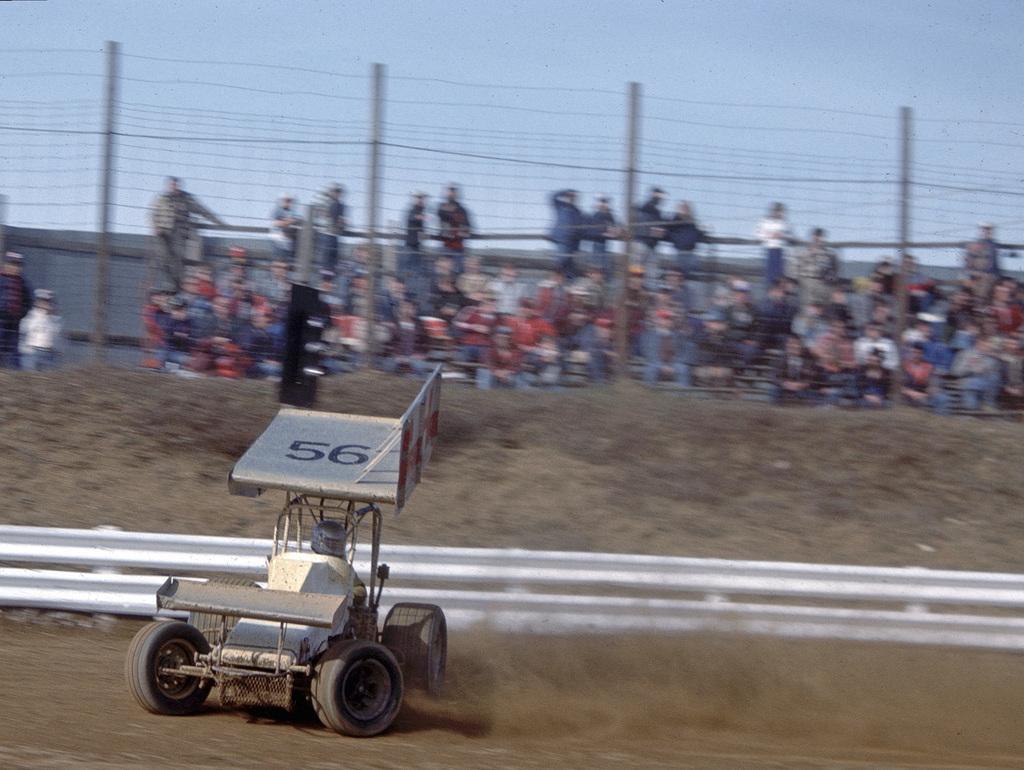Could you give a brief overview of what you see in this image? In this image, at the left side there is a racing car, at the background there is a fencing and there are some people sitting, at the top there is a blue color sky. 